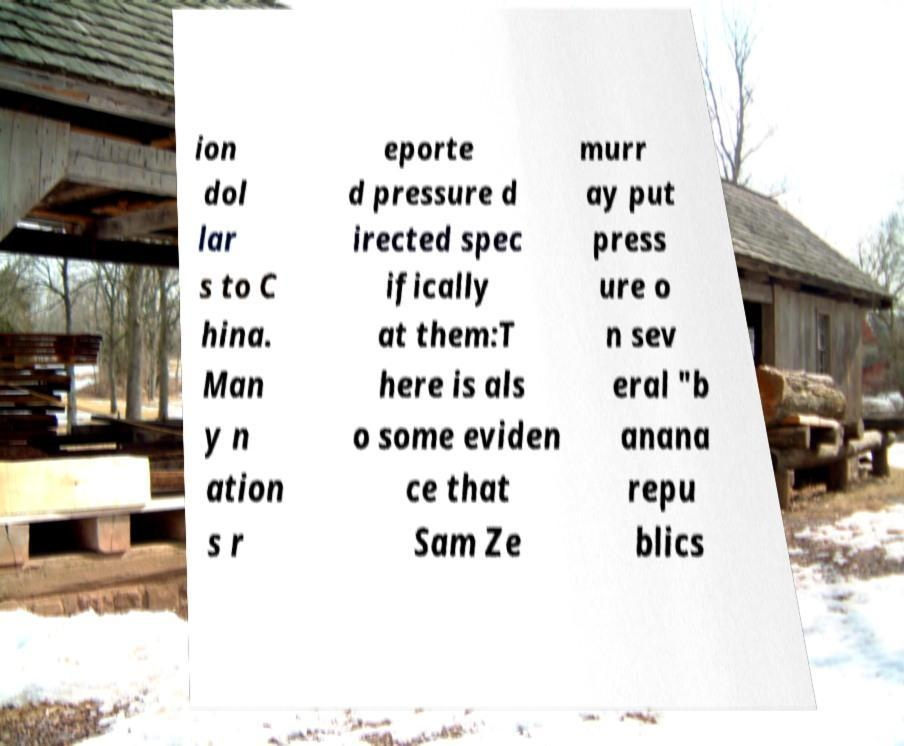Please read and relay the text visible in this image. What does it say? ion dol lar s to C hina. Man y n ation s r eporte d pressure d irected spec ifically at them:T here is als o some eviden ce that Sam Ze murr ay put press ure o n sev eral "b anana repu blics 